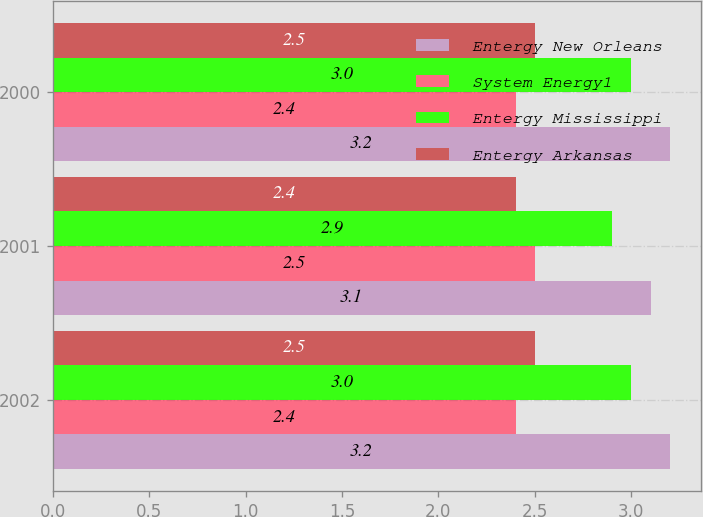<chart> <loc_0><loc_0><loc_500><loc_500><stacked_bar_chart><ecel><fcel>2002<fcel>2001<fcel>2000<nl><fcel>Entergy New Orleans<fcel>3.2<fcel>3.1<fcel>3.2<nl><fcel>System Energy1<fcel>2.4<fcel>2.5<fcel>2.4<nl><fcel>Entergy Mississippi<fcel>3<fcel>2.9<fcel>3<nl><fcel>Entergy Arkansas<fcel>2.5<fcel>2.4<fcel>2.5<nl></chart> 